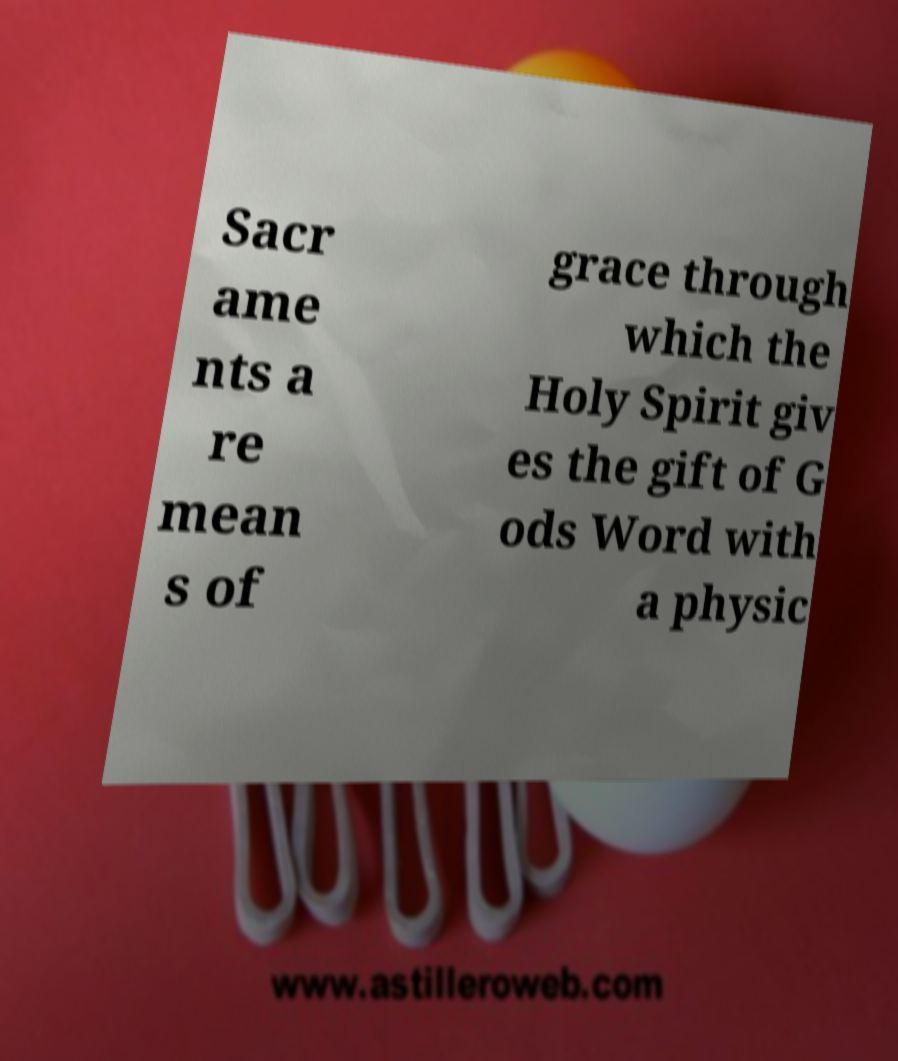For documentation purposes, I need the text within this image transcribed. Could you provide that? Sacr ame nts a re mean s of grace through which the Holy Spirit giv es the gift of G ods Word with a physic 